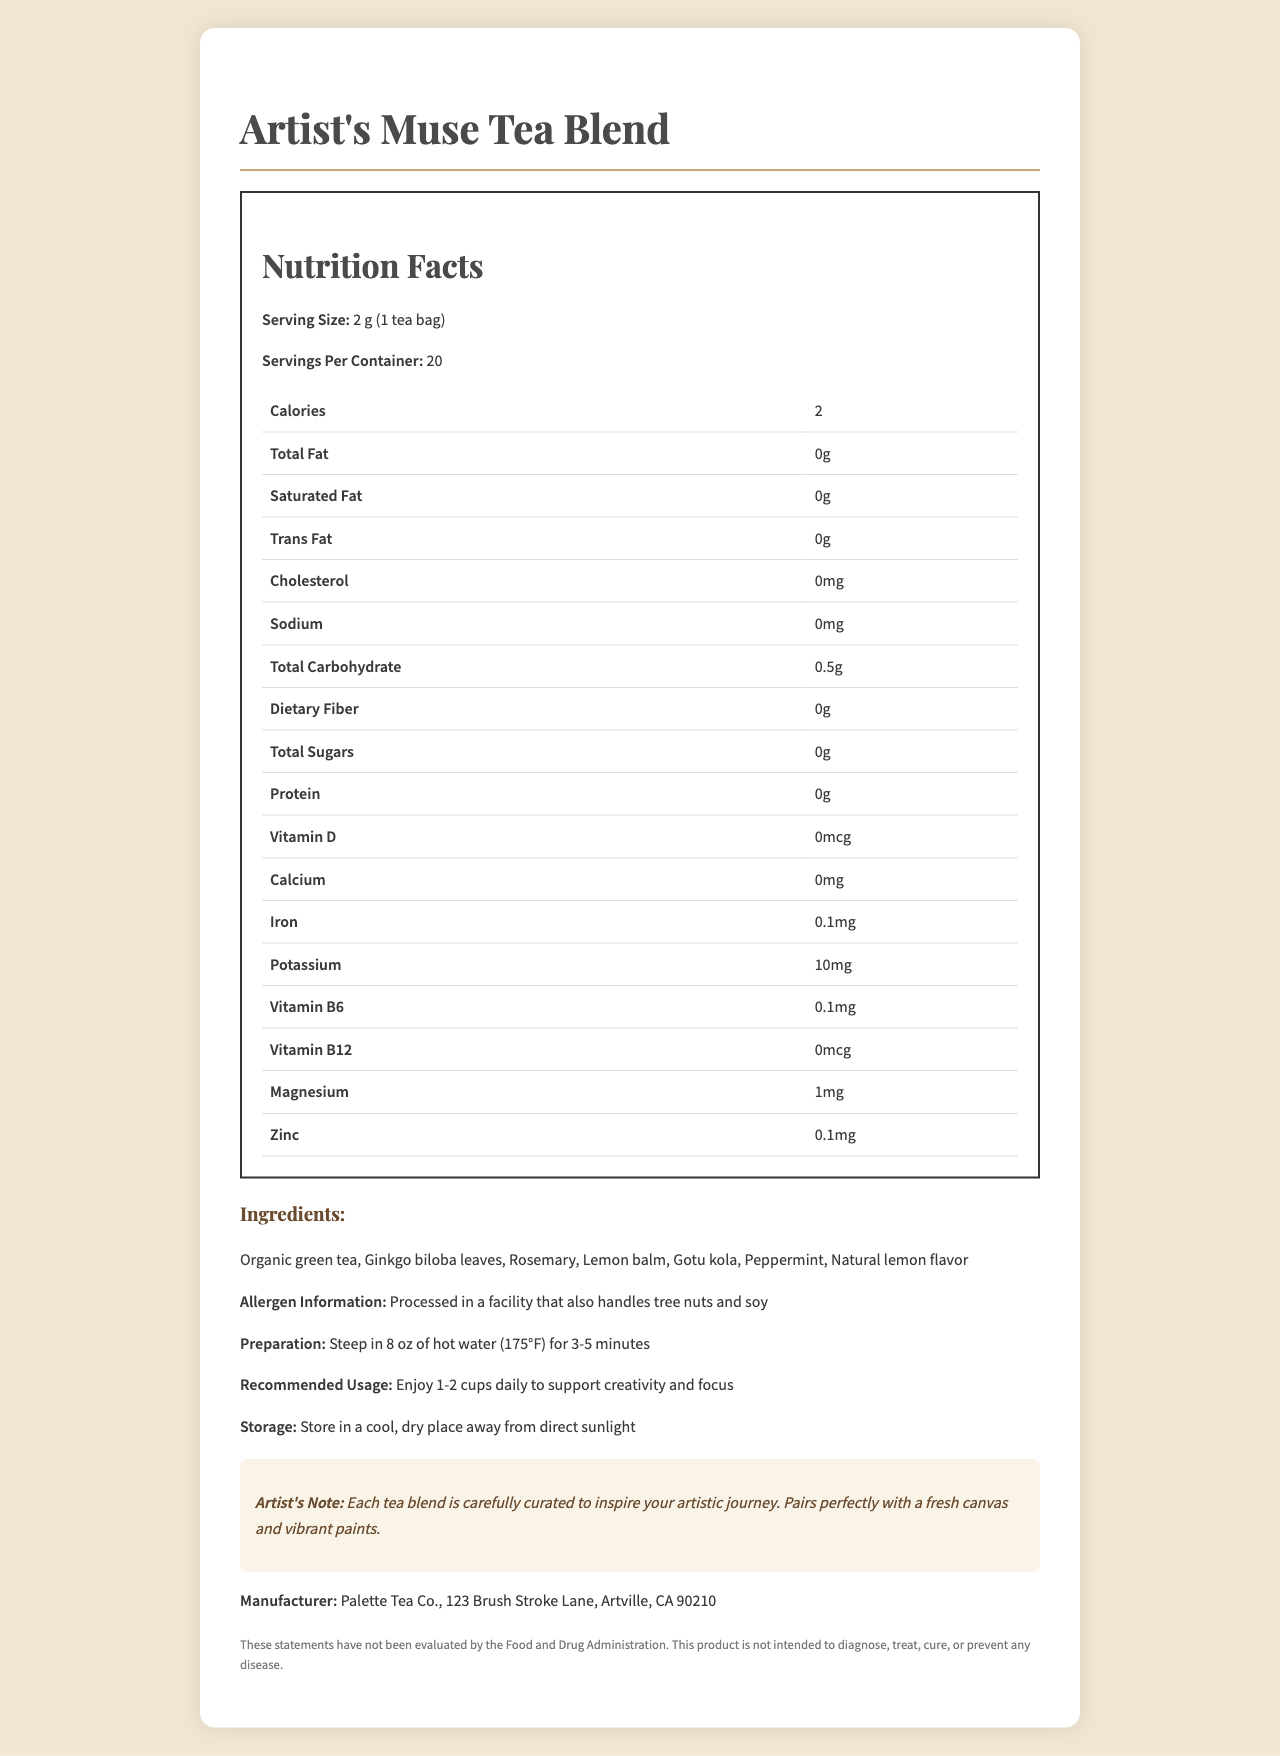what is the serving size of Artist's Muse Tea Blend? The serving size is clearly mentioned at the beginning of the nutrition facts label.
Answer: 2 g (1 tea bag) how many servings are there in one container? The document states there are 20 servings per container.
Answer: 20 how many calories per serving are in the tea blend? The calories per serving are listed as 2.
Answer: 2 how much iron is in each serving? The nutrition facts indicate that each serving contains 0.1 mg of iron.
Answer: 0.1 mg how should the tea be prepared? The preparation instructions mention steeping the tea in hot water for 3-5 minutes.
Answer: Steep in 8 oz of hot water (175°F) for 3-5 minutes how much vitamin B6 is in each serving of the tea? The document specifies that there is 0.1 mg of vitamin B6 per serving.
Answer: 0.1 mg which ingredient is not listed in the tea blend's ingredients? A. Peppermint B. Lavender C. Lemon balm The ingredients listed are Organic green tea, Ginkgo biloba leaves, Rosemary, Lemon balm, Gotu kola, Peppermint, and Natural lemon flavor. Lavender is not listed.
Answer: B. Lavender where is the tea blend processed? A. In a tree nut facility B. In a dairy facility C. In a fish and seafood facility D. In a facility that handles tree nuts and soy The allergen information states that the product is processed in a facility that handles tree nuts and soy.
Answer: D. In a facility that handles tree nuts and soy is there any cholesterol in the tea blend? The nutrition facts show 0 mg of cholesterol per serving, indicating there is no cholesterol in the tea blend.
Answer: No summarize the main idea of the document The summary includes the primary details of the document, highlighting its purpose, key content, and target audience.
Answer: The document provides detailed nutritional information for the "Artist's Muse Tea Blend". It includes serving size, nutritional content per serving, a list of ingredients, allergen information, preparation instructions, recommended usage, storage instructions, and a note from the artist. The tea blend is marketed to enhance creativity and focus. what are the recommended storage conditions for the tea blend? The storage instructions specifically mention keeping the tea in a cool, dry place away from direct sunlight.
Answer: Store in a cool, dry place away from direct sunlight what is the address of the manufacturer? The manufacturer's address is provided at the end of the document.
Answer: Palette Tea Co., 123 Brush Stroke Lane, Artville, CA 90210 does the tea blend contain any trans fat? The nutrition facts label shows 0 grams of trans fat per serving.
Answer: No does the tea label indicate if the product is evaluated by the FDA? The disclaimer clearly states that these statements have not been evaluated by the Food and Drug Administration (FDA).
Answer: No what kind of flavors are included in the tea blend? The ingredients list mentions natural lemon flavor as one of the ingredients.
Answer: Natural lemon flavor how long is the tea recommended to be steeped in hot water? A. 1-2 minutes B. 3-5 minutes C. 5-7 minutes D. 7-10 minutes The preparation instructions specify steeping the tea for 3-5 minutes in hot water.
Answer: B. 3-5 minutes what artistic elements are suggested to enjoy with the tea blend? The artist's note suggests enjoying the tea blend along with a fresh canvas and vibrant paints.
Answer: Each tea blend is carefully curated to inspire your artistic journey. Pairs perfectly with a fresh canvas and vibrant paints. does the tea blend provide any fiber? The nutrition facts indicate 0 grams of dietary fiber per serving.
Answer: No what kind of potassium content does the tea blend have? The document states that the tea blend contains 10 mg of potassium per serving.
Answer: 10 mg per serving what are the health claims made by the tea blend? The disclaimer states that the product is not intended to diagnose, treat, cure, or prevent any disease.
Answer: This product is not intended to diagnose, treat, cure, or prevent any disease. what is the tea heritage? The document does not provide information about the heritage of the tea used in the blend.
Answer: Cannot be determined 